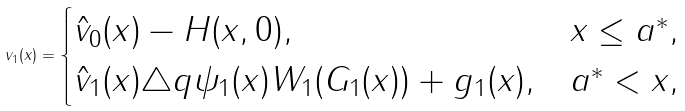<formula> <loc_0><loc_0><loc_500><loc_500>v _ { 1 } ( x ) = \begin{cases} \hat { v } _ { 0 } ( x ) - H ( x , 0 ) , & x \leq a ^ { * } , \\ \hat { v } _ { 1 } ( x ) \triangle q \psi _ { 1 } ( x ) W _ { 1 } ( G _ { 1 } ( x ) ) + g _ { 1 } ( x ) , & a ^ { * } < x , \end{cases}</formula> 